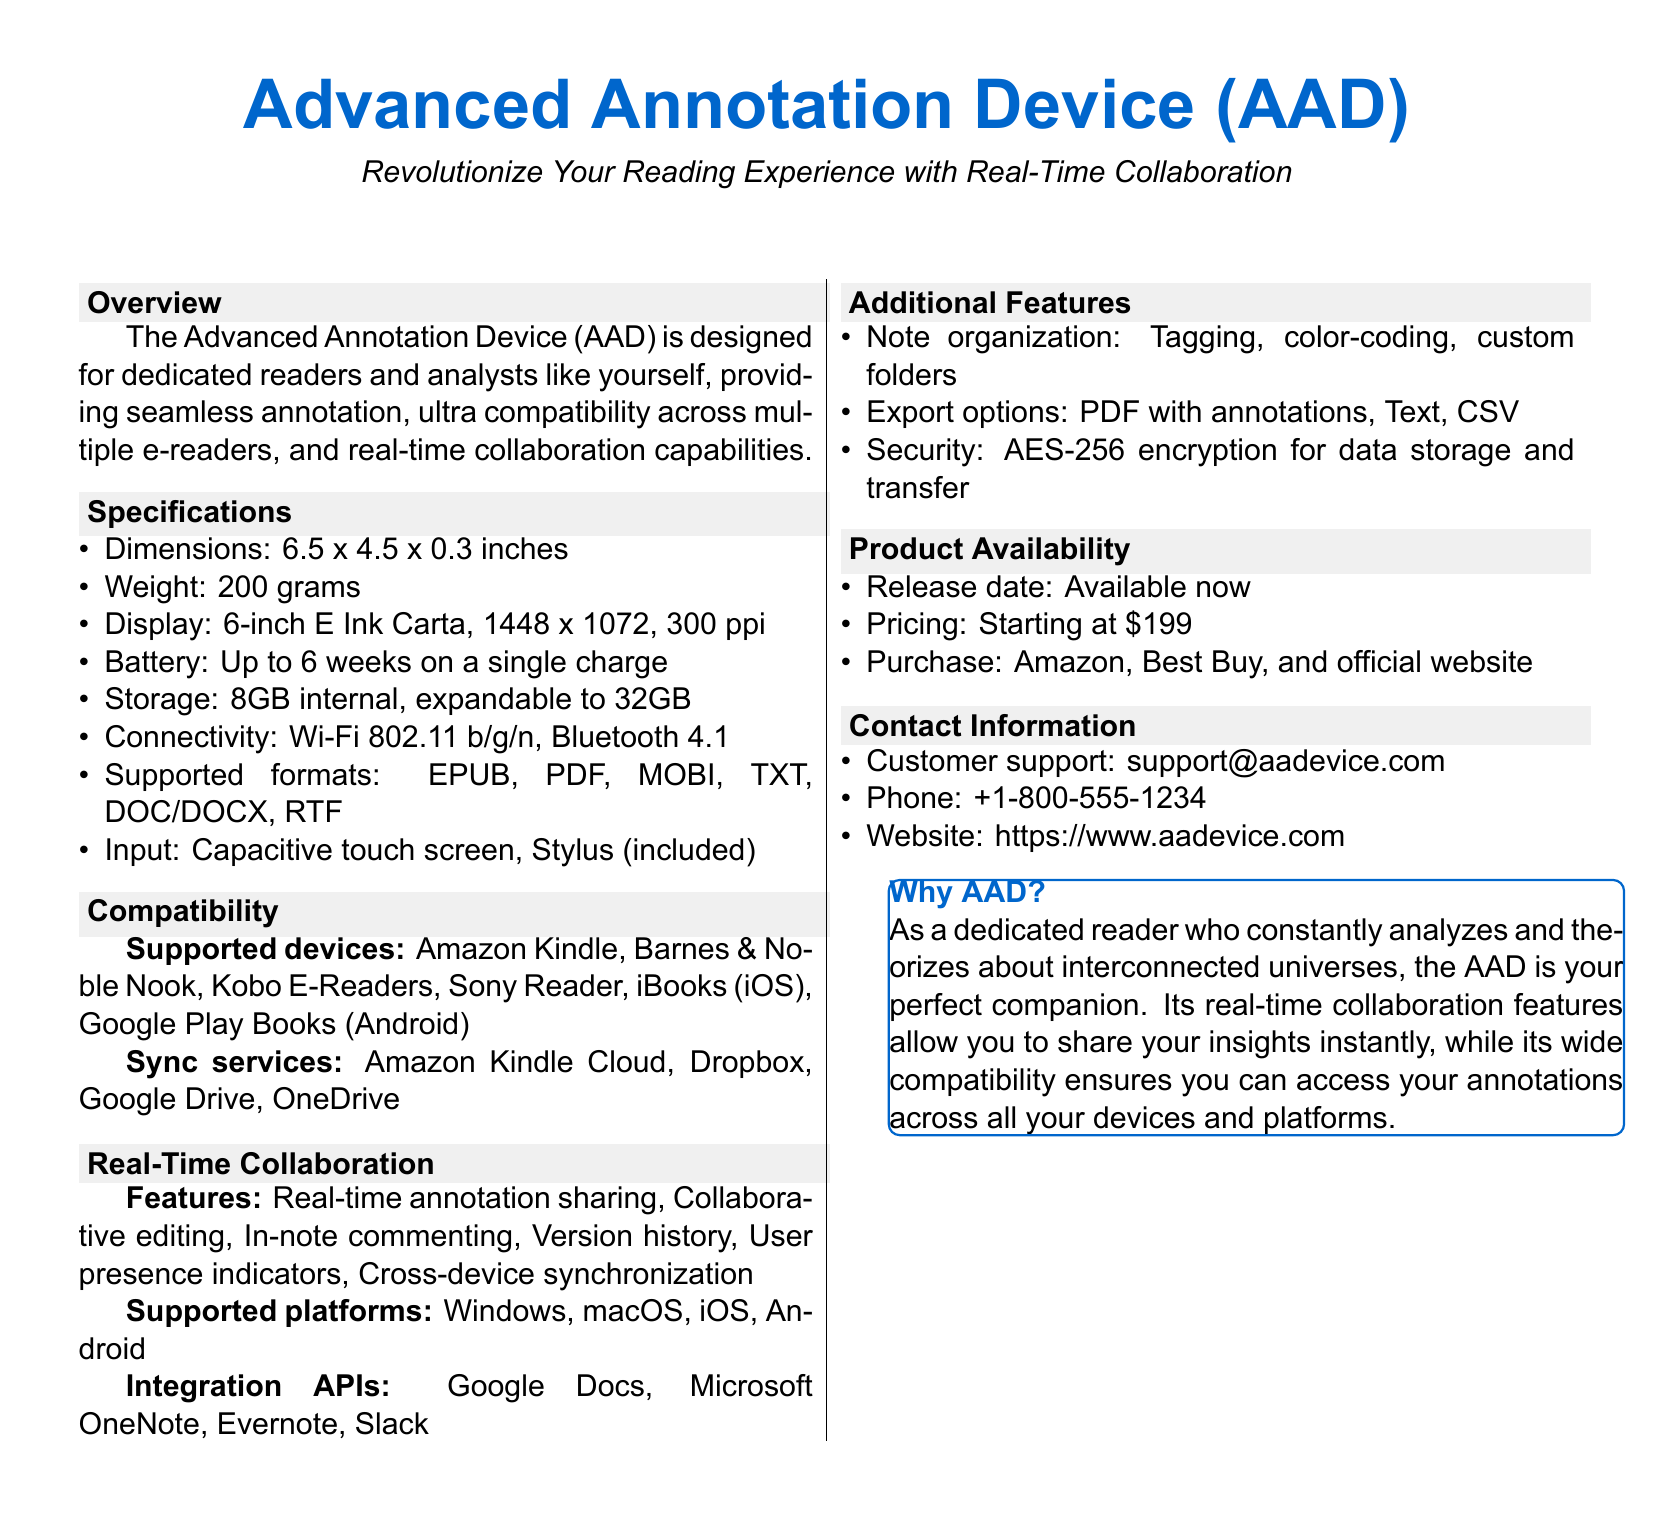What is the weight of the AAD? The weight of the Advanced Annotation Device is specified in the document under the specifications section, which shows it as 200 grams.
Answer: 200 grams What is the maximum expandable storage of the AAD? The storage capacity details indicate that the internal storage of the AAD is expandable up to 32GB.
Answer: 32GB Which display technology does the AAD use? The specifications state that the display of the AAD is a 6-inch E Ink Carta.
Answer: E Ink Carta What is the battery life of the AAD on a single charge? The document specifies that the battery can last up to 6 weeks, which is mentioned in the specifications.
Answer: Up to 6 weeks Which annotation feature allows multiple users to contribute simultaneously? The document highlights "Collaborative editing" as a feature of real-time collaboration, indicating the ability for multiple users to contribute.
Answer: Collaborative editing Which file formats are supported by the AAD? In the specifications, a list of supported formats is provided, including EPUB, PDF, MOBI, TXT, DOC/DOCX, and RTF.
Answer: EPUB, PDF, MOBI, TXT, DOC/DOCX, RTF What is the starting price of the AAD? The product availability section indicates the starting price of the AAD, which is mentioned explicitly.
Answer: $199 Which services does the AAD sync with? The compatibility section lists sync services including Amazon Kindle Cloud, Dropbox, Google Drive, and OneDrive.
Answer: Amazon Kindle Cloud, Dropbox, Google Drive, OneDrive What type of encryption is used for data security in the AAD? The additional features section specifies that the AAD uses AES-256 encryption for secure data storage and transfer.
Answer: AES-256 